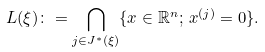<formula> <loc_0><loc_0><loc_500><loc_500>L ( \xi ) \colon = \underset { j \in J ^ { * } ( \xi ) } { \bigcap } \{ x \in \mathbb { R } ^ { n } ; \, x ^ { ( j ) } = 0 \} .</formula> 